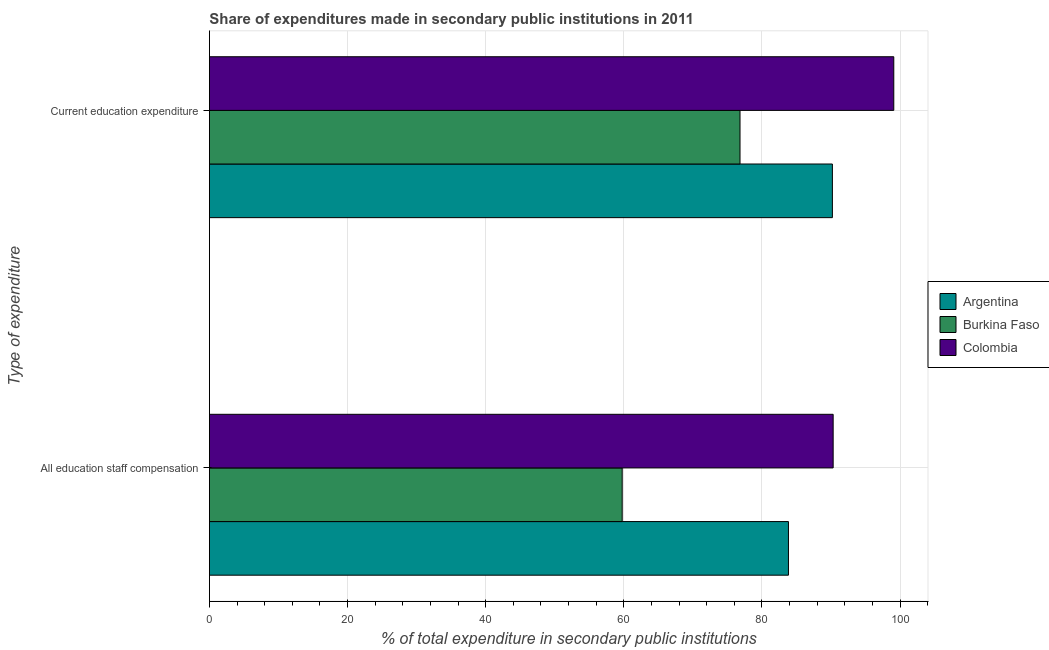How many different coloured bars are there?
Ensure brevity in your answer.  3. Are the number of bars per tick equal to the number of legend labels?
Ensure brevity in your answer.  Yes. Are the number of bars on each tick of the Y-axis equal?
Ensure brevity in your answer.  Yes. How many bars are there on the 2nd tick from the top?
Offer a terse response. 3. How many bars are there on the 1st tick from the bottom?
Offer a very short reply. 3. What is the label of the 1st group of bars from the top?
Give a very brief answer. Current education expenditure. What is the expenditure in education in Colombia?
Provide a short and direct response. 99.09. Across all countries, what is the maximum expenditure in education?
Your answer should be very brief. 99.09. Across all countries, what is the minimum expenditure in staff compensation?
Keep it short and to the point. 59.77. In which country was the expenditure in education maximum?
Your response must be concise. Colombia. In which country was the expenditure in staff compensation minimum?
Your response must be concise. Burkina Faso. What is the total expenditure in staff compensation in the graph?
Offer a very short reply. 233.93. What is the difference between the expenditure in education in Colombia and that in Argentina?
Offer a very short reply. 8.89. What is the difference between the expenditure in staff compensation in Burkina Faso and the expenditure in education in Colombia?
Provide a succinct answer. -39.32. What is the average expenditure in staff compensation per country?
Make the answer very short. 77.98. What is the difference between the expenditure in education and expenditure in staff compensation in Argentina?
Provide a short and direct response. 6.36. In how many countries, is the expenditure in education greater than 88 %?
Provide a succinct answer. 2. What is the ratio of the expenditure in education in Burkina Faso to that in Argentina?
Ensure brevity in your answer.  0.85. In how many countries, is the expenditure in education greater than the average expenditure in education taken over all countries?
Provide a short and direct response. 2. What does the 3rd bar from the top in All education staff compensation represents?
Provide a succinct answer. Argentina. Are all the bars in the graph horizontal?
Your response must be concise. Yes. What is the difference between two consecutive major ticks on the X-axis?
Give a very brief answer. 20. Are the values on the major ticks of X-axis written in scientific E-notation?
Your answer should be very brief. No. Where does the legend appear in the graph?
Offer a terse response. Center right. What is the title of the graph?
Keep it short and to the point. Share of expenditures made in secondary public institutions in 2011. What is the label or title of the X-axis?
Provide a succinct answer. % of total expenditure in secondary public institutions. What is the label or title of the Y-axis?
Keep it short and to the point. Type of expenditure. What is the % of total expenditure in secondary public institutions of Argentina in All education staff compensation?
Provide a short and direct response. 83.84. What is the % of total expenditure in secondary public institutions of Burkina Faso in All education staff compensation?
Your answer should be very brief. 59.77. What is the % of total expenditure in secondary public institutions of Colombia in All education staff compensation?
Your answer should be very brief. 90.32. What is the % of total expenditure in secondary public institutions of Argentina in Current education expenditure?
Your answer should be very brief. 90.2. What is the % of total expenditure in secondary public institutions in Burkina Faso in Current education expenditure?
Ensure brevity in your answer.  76.83. What is the % of total expenditure in secondary public institutions of Colombia in Current education expenditure?
Provide a succinct answer. 99.09. Across all Type of expenditure, what is the maximum % of total expenditure in secondary public institutions of Argentina?
Offer a very short reply. 90.2. Across all Type of expenditure, what is the maximum % of total expenditure in secondary public institutions of Burkina Faso?
Offer a very short reply. 76.83. Across all Type of expenditure, what is the maximum % of total expenditure in secondary public institutions in Colombia?
Give a very brief answer. 99.09. Across all Type of expenditure, what is the minimum % of total expenditure in secondary public institutions of Argentina?
Keep it short and to the point. 83.84. Across all Type of expenditure, what is the minimum % of total expenditure in secondary public institutions in Burkina Faso?
Give a very brief answer. 59.77. Across all Type of expenditure, what is the minimum % of total expenditure in secondary public institutions in Colombia?
Make the answer very short. 90.32. What is the total % of total expenditure in secondary public institutions in Argentina in the graph?
Ensure brevity in your answer.  174.05. What is the total % of total expenditure in secondary public institutions in Burkina Faso in the graph?
Give a very brief answer. 136.6. What is the total % of total expenditure in secondary public institutions in Colombia in the graph?
Offer a very short reply. 189.41. What is the difference between the % of total expenditure in secondary public institutions in Argentina in All education staff compensation and that in Current education expenditure?
Provide a short and direct response. -6.36. What is the difference between the % of total expenditure in secondary public institutions in Burkina Faso in All education staff compensation and that in Current education expenditure?
Offer a very short reply. -17.06. What is the difference between the % of total expenditure in secondary public institutions of Colombia in All education staff compensation and that in Current education expenditure?
Your answer should be compact. -8.78. What is the difference between the % of total expenditure in secondary public institutions of Argentina in All education staff compensation and the % of total expenditure in secondary public institutions of Burkina Faso in Current education expenditure?
Offer a very short reply. 7.01. What is the difference between the % of total expenditure in secondary public institutions of Argentina in All education staff compensation and the % of total expenditure in secondary public institutions of Colombia in Current education expenditure?
Make the answer very short. -15.25. What is the difference between the % of total expenditure in secondary public institutions of Burkina Faso in All education staff compensation and the % of total expenditure in secondary public institutions of Colombia in Current education expenditure?
Provide a succinct answer. -39.32. What is the average % of total expenditure in secondary public institutions in Argentina per Type of expenditure?
Make the answer very short. 87.02. What is the average % of total expenditure in secondary public institutions of Burkina Faso per Type of expenditure?
Your response must be concise. 68.3. What is the average % of total expenditure in secondary public institutions in Colombia per Type of expenditure?
Give a very brief answer. 94.71. What is the difference between the % of total expenditure in secondary public institutions of Argentina and % of total expenditure in secondary public institutions of Burkina Faso in All education staff compensation?
Make the answer very short. 24.07. What is the difference between the % of total expenditure in secondary public institutions of Argentina and % of total expenditure in secondary public institutions of Colombia in All education staff compensation?
Your answer should be very brief. -6.47. What is the difference between the % of total expenditure in secondary public institutions of Burkina Faso and % of total expenditure in secondary public institutions of Colombia in All education staff compensation?
Your answer should be compact. -30.55. What is the difference between the % of total expenditure in secondary public institutions in Argentina and % of total expenditure in secondary public institutions in Burkina Faso in Current education expenditure?
Offer a terse response. 13.38. What is the difference between the % of total expenditure in secondary public institutions in Argentina and % of total expenditure in secondary public institutions in Colombia in Current education expenditure?
Provide a succinct answer. -8.89. What is the difference between the % of total expenditure in secondary public institutions of Burkina Faso and % of total expenditure in secondary public institutions of Colombia in Current education expenditure?
Offer a very short reply. -22.26. What is the ratio of the % of total expenditure in secondary public institutions in Argentina in All education staff compensation to that in Current education expenditure?
Your answer should be very brief. 0.93. What is the ratio of the % of total expenditure in secondary public institutions of Burkina Faso in All education staff compensation to that in Current education expenditure?
Your answer should be compact. 0.78. What is the ratio of the % of total expenditure in secondary public institutions in Colombia in All education staff compensation to that in Current education expenditure?
Your answer should be compact. 0.91. What is the difference between the highest and the second highest % of total expenditure in secondary public institutions of Argentina?
Offer a very short reply. 6.36. What is the difference between the highest and the second highest % of total expenditure in secondary public institutions of Burkina Faso?
Provide a short and direct response. 17.06. What is the difference between the highest and the second highest % of total expenditure in secondary public institutions in Colombia?
Offer a terse response. 8.78. What is the difference between the highest and the lowest % of total expenditure in secondary public institutions in Argentina?
Provide a succinct answer. 6.36. What is the difference between the highest and the lowest % of total expenditure in secondary public institutions in Burkina Faso?
Ensure brevity in your answer.  17.06. What is the difference between the highest and the lowest % of total expenditure in secondary public institutions in Colombia?
Your answer should be very brief. 8.78. 